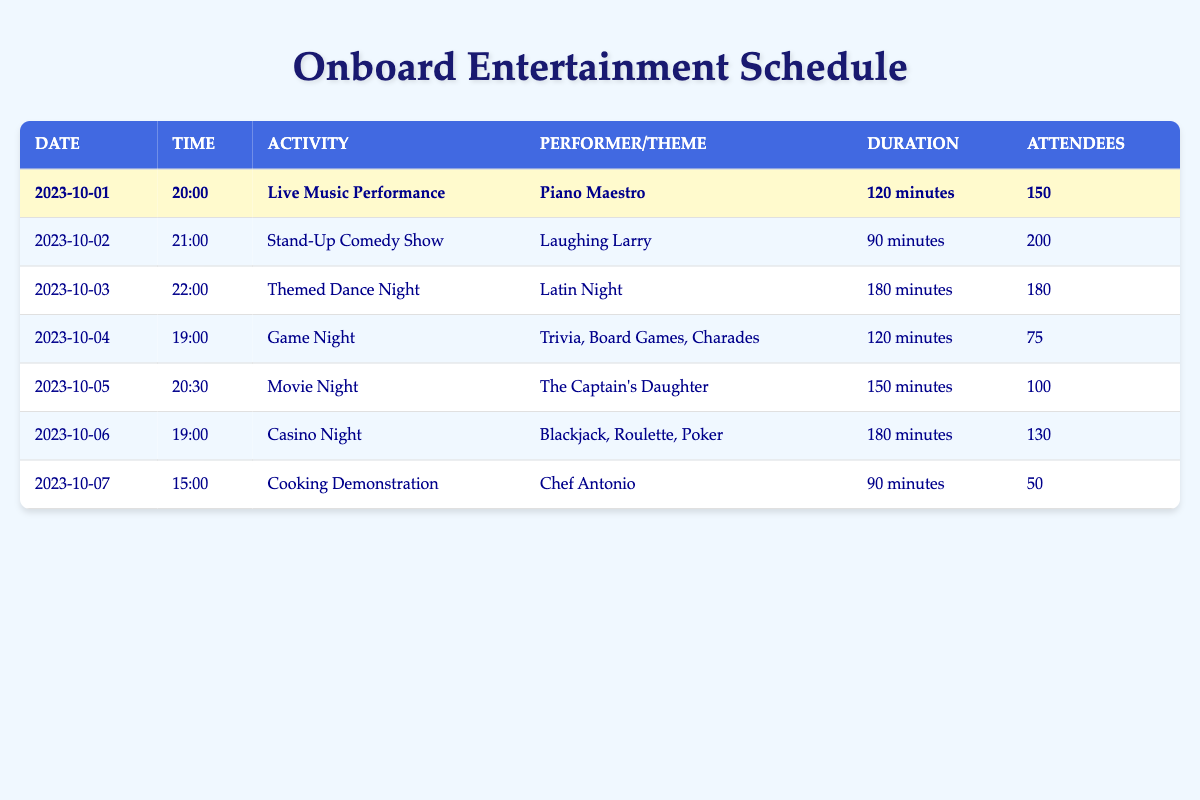What is the activity with the highest attendance? By reviewing the "Attendees" column, I see that the Stand-Up Comedy Show has 200 attendees, which is higher than all other activities listed in the table.
Answer: Stand-Up Comedy Show Which activity lasted the longest? I compare the "Duration" column of all activities. The Themed Dance Night has a duration of 180 minutes, which is the highest compared to others.
Answer: Themed Dance Night How many attendees were there at Live Music Performance and Movie Night combined? I find the attendees for Live Music Performance (150) and Movie Night (100). By adding them together, I get 150 + 100 = 250.
Answer: 250 Was there a cooking demonstration held on board? Looking at the activities listed, I see that there is indeed a Cooking Demonstration scheduled on 2023-10-07.
Answer: Yes What is the average number of attendees across all activities? I gather the total attendees from all activities: 150 + 200 + 180 + 75 + 100 + 130 + 50 = 985. There are 7 activities, so I divide: 985 / 7 = approximately 140.71.
Answer: 140.71 Is there a live music performance scheduled on 2023-10-02? The table shows that the Live Music Performance is scheduled for 2023-10-01, and on 2023-10-02, there is a Stand-Up Comedy Show instead.
Answer: No How many activities had more than 100 attendees? I count the activities with more than 100 attendees: the Stand-Up Comedy Show (200), Themed Dance Night (180), Live Music Performance (150), and Casino Night (130). That's a total of 4 activities.
Answer: 4 What is the difference in attendees between Themed Dance Night and Game Night? I compare the attendees: Themed Dance Night has 180 and Game Night has 75. The difference is calculated as 180 - 75 = 105.
Answer: 105 Which activity features a specific performer named Chef Antonio? In reviewing the table, I note that the Cooking Demonstration prominently features Chef Antonio as the performer.
Answer: Cooking Demonstration 